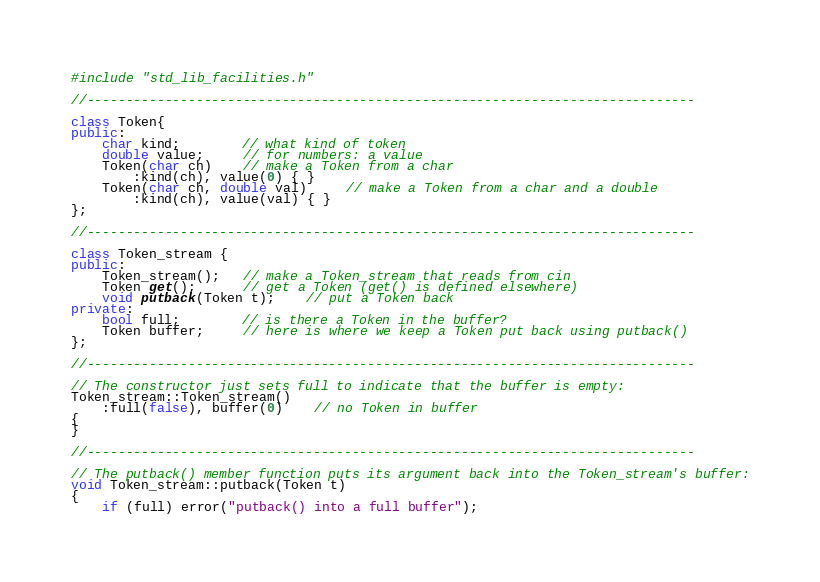Convert code to text. <code><loc_0><loc_0><loc_500><loc_500><_C++_>#include "std_lib_facilities.h"

//------------------------------------------------------------------------------

class Token{
public:
    char kind;        // what kind of token
    double value;     // for numbers: a value 
    Token(char ch)    // make a Token from a char
        :kind(ch), value(0) { }
    Token(char ch, double val)     // make a Token from a char and a double
        :kind(ch), value(val) { }
};

//------------------------------------------------------------------------------

class Token_stream {
public:
    Token_stream();   // make a Token_stream that reads from cin
    Token get();      // get a Token (get() is defined elsewhere)
    void putback(Token t);    // put a Token back
private:
    bool full;        // is there a Token in the buffer?
    Token buffer;     // here is where we keep a Token put back using putback()
};

//------------------------------------------------------------------------------

// The constructor just sets full to indicate that the buffer is empty:
Token_stream::Token_stream()
    :full(false), buffer(0)    // no Token in buffer
{
}

//------------------------------------------------------------------------------

// The putback() member function puts its argument back into the Token_stream's buffer:
void Token_stream::putback(Token t)
{
    if (full) error("putback() into a full buffer");</code> 